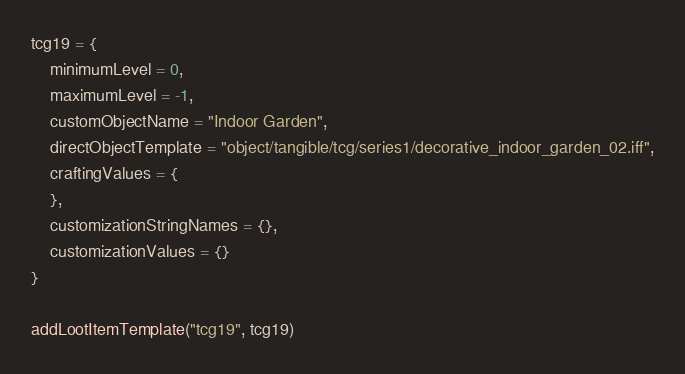<code> <loc_0><loc_0><loc_500><loc_500><_Lua_>tcg19 = {
	minimumLevel = 0,
	maximumLevel = -1,
	customObjectName = "Indoor Garden",
	directObjectTemplate = "object/tangible/tcg/series1/decorative_indoor_garden_02.iff",
	craftingValues = {
	},
	customizationStringNames = {},
	customizationValues = {}
}

addLootItemTemplate("tcg19", tcg19)
</code> 